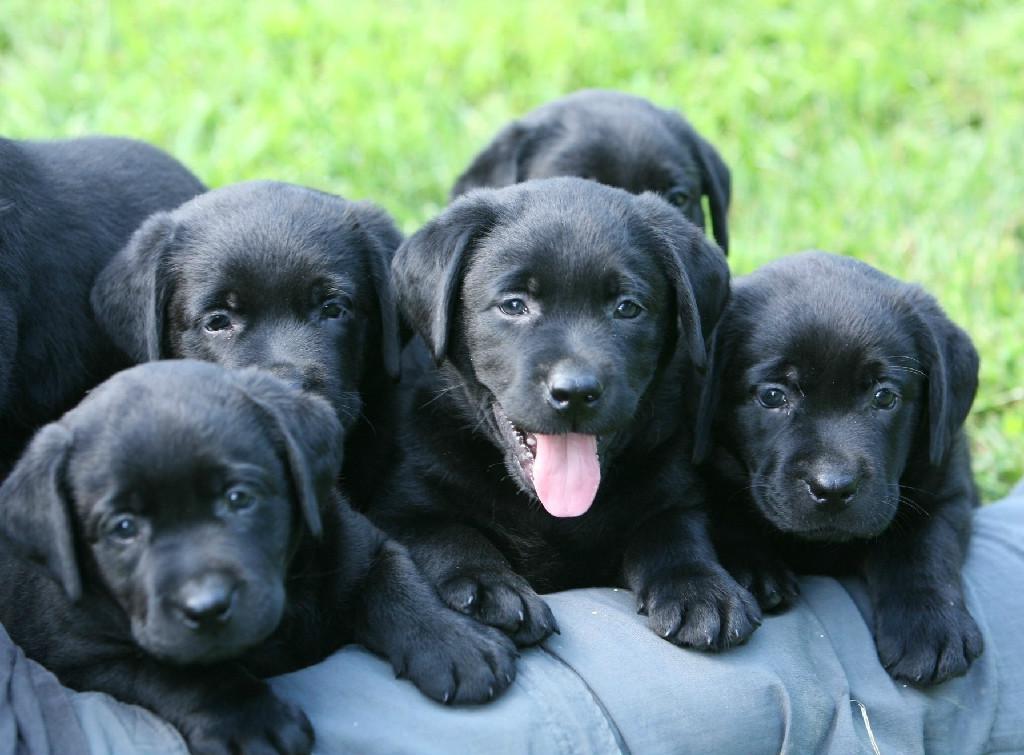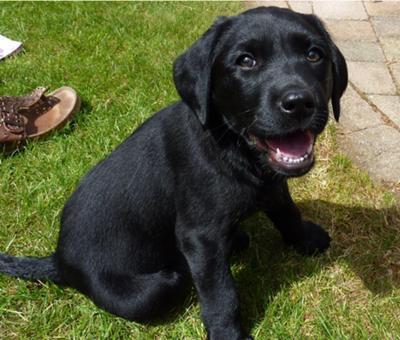The first image is the image on the left, the second image is the image on the right. Analyze the images presented: Is the assertion "The left image contains no more than one dog." valid? Answer yes or no. No. The first image is the image on the left, the second image is the image on the right. For the images displayed, is the sentence "Each image contains only one dog, and each dog is a black lab pup." factually correct? Answer yes or no. No. 